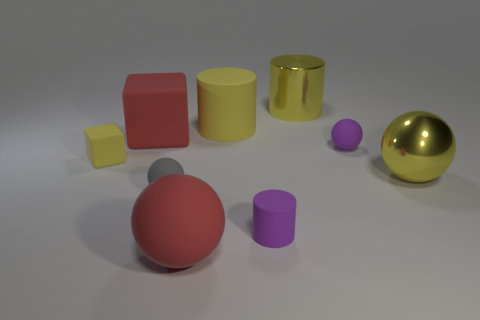What size is the cube that is the same color as the metal sphere? The cube that matches the color of the metallic sphere is the smaller one among the two cubes present. 